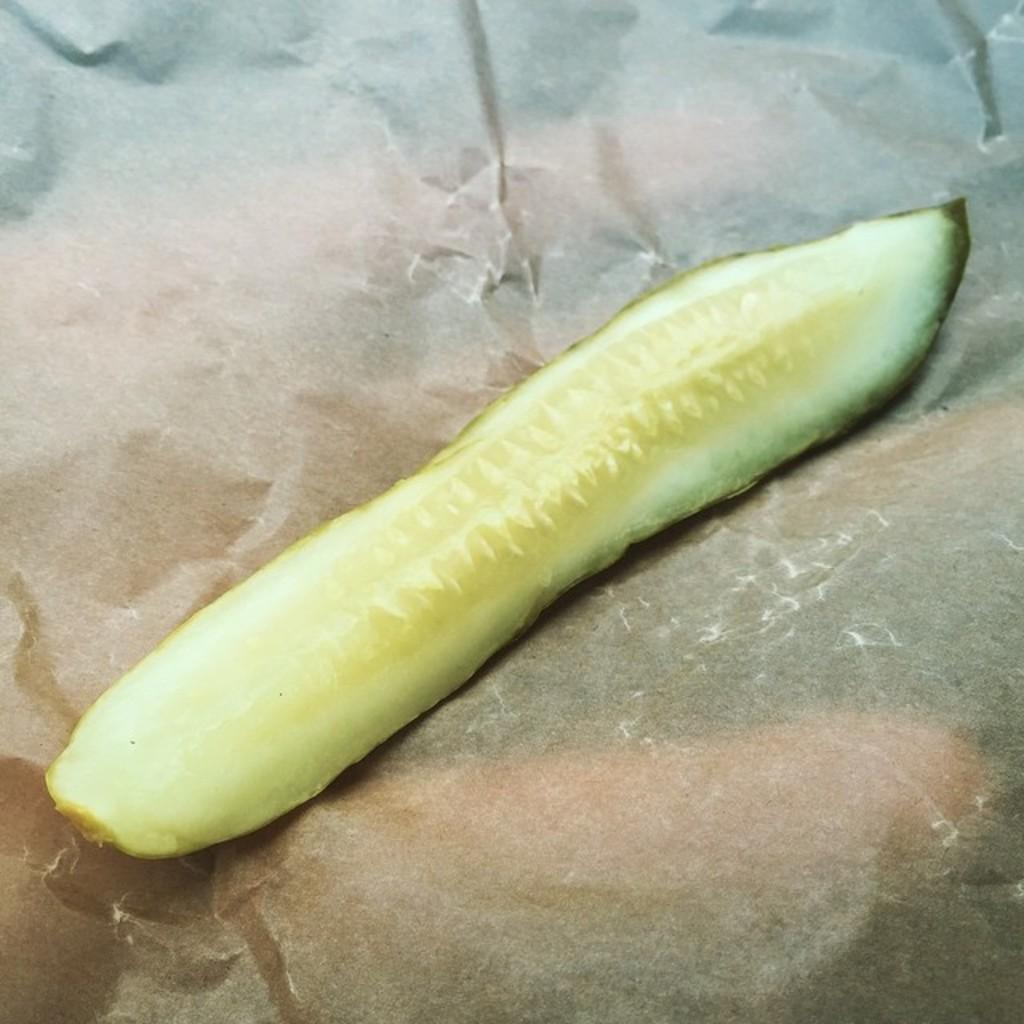What type of vegetable is visible in the image? There is a peeled cucumber in the image. How many giants are holding apples in the image? There are no giants or apples present in the image; it only features a peeled cucumber. 